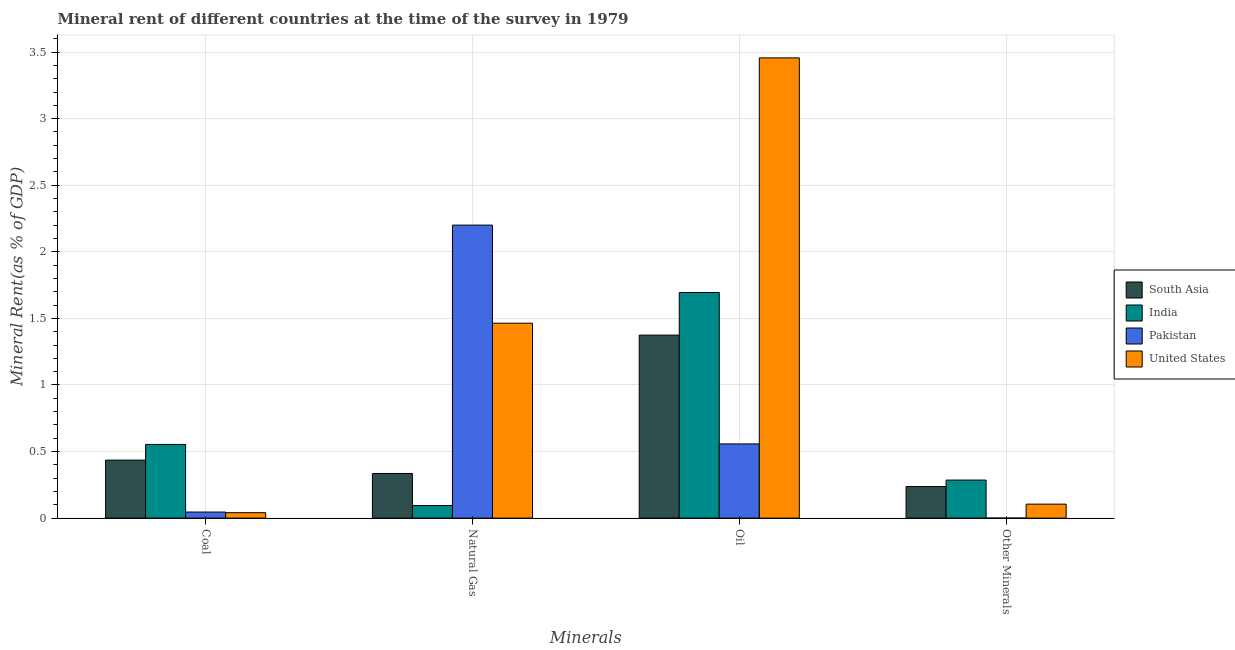How many different coloured bars are there?
Keep it short and to the point. 4. How many groups of bars are there?
Give a very brief answer. 4. Are the number of bars per tick equal to the number of legend labels?
Ensure brevity in your answer.  Yes. How many bars are there on the 2nd tick from the right?
Give a very brief answer. 4. What is the label of the 2nd group of bars from the left?
Your answer should be very brief. Natural Gas. What is the natural gas rent in South Asia?
Your answer should be compact. 0.34. Across all countries, what is the maximum coal rent?
Offer a very short reply. 0.55. Across all countries, what is the minimum natural gas rent?
Make the answer very short. 0.09. What is the total  rent of other minerals in the graph?
Your answer should be very brief. 0.63. What is the difference between the  rent of other minerals in South Asia and that in United States?
Give a very brief answer. 0.13. What is the difference between the  rent of other minerals in Pakistan and the oil rent in South Asia?
Give a very brief answer. -1.37. What is the average  rent of other minerals per country?
Provide a succinct answer. 0.16. What is the difference between the  rent of other minerals and coal rent in South Asia?
Your answer should be very brief. -0.2. In how many countries, is the coal rent greater than 2.1 %?
Your answer should be very brief. 0. What is the ratio of the  rent of other minerals in India to that in United States?
Provide a succinct answer. 2.72. What is the difference between the highest and the second highest oil rent?
Offer a terse response. 1.76. What is the difference between the highest and the lowest oil rent?
Give a very brief answer. 2.9. Is it the case that in every country, the sum of the coal rent and natural gas rent is greater than the oil rent?
Provide a succinct answer. No. What is the difference between two consecutive major ticks on the Y-axis?
Ensure brevity in your answer.  0.5. Where does the legend appear in the graph?
Provide a succinct answer. Center right. How many legend labels are there?
Your response must be concise. 4. What is the title of the graph?
Offer a terse response. Mineral rent of different countries at the time of the survey in 1979. Does "Ghana" appear as one of the legend labels in the graph?
Your response must be concise. No. What is the label or title of the X-axis?
Your answer should be compact. Minerals. What is the label or title of the Y-axis?
Give a very brief answer. Mineral Rent(as % of GDP). What is the Mineral Rent(as % of GDP) of South Asia in Coal?
Your answer should be very brief. 0.44. What is the Mineral Rent(as % of GDP) in India in Coal?
Ensure brevity in your answer.  0.55. What is the Mineral Rent(as % of GDP) of Pakistan in Coal?
Offer a terse response. 0.05. What is the Mineral Rent(as % of GDP) in United States in Coal?
Your answer should be compact. 0.04. What is the Mineral Rent(as % of GDP) in South Asia in Natural Gas?
Your answer should be compact. 0.34. What is the Mineral Rent(as % of GDP) in India in Natural Gas?
Ensure brevity in your answer.  0.09. What is the Mineral Rent(as % of GDP) in Pakistan in Natural Gas?
Ensure brevity in your answer.  2.2. What is the Mineral Rent(as % of GDP) of United States in Natural Gas?
Your response must be concise. 1.46. What is the Mineral Rent(as % of GDP) in South Asia in Oil?
Your answer should be compact. 1.37. What is the Mineral Rent(as % of GDP) in India in Oil?
Your response must be concise. 1.69. What is the Mineral Rent(as % of GDP) in Pakistan in Oil?
Make the answer very short. 0.56. What is the Mineral Rent(as % of GDP) of United States in Oil?
Ensure brevity in your answer.  3.46. What is the Mineral Rent(as % of GDP) of South Asia in Other Minerals?
Provide a succinct answer. 0.24. What is the Mineral Rent(as % of GDP) in India in Other Minerals?
Your answer should be compact. 0.29. What is the Mineral Rent(as % of GDP) in Pakistan in Other Minerals?
Keep it short and to the point. 0. What is the Mineral Rent(as % of GDP) in United States in Other Minerals?
Offer a terse response. 0.1. Across all Minerals, what is the maximum Mineral Rent(as % of GDP) in South Asia?
Ensure brevity in your answer.  1.37. Across all Minerals, what is the maximum Mineral Rent(as % of GDP) of India?
Give a very brief answer. 1.69. Across all Minerals, what is the maximum Mineral Rent(as % of GDP) of Pakistan?
Your answer should be compact. 2.2. Across all Minerals, what is the maximum Mineral Rent(as % of GDP) in United States?
Ensure brevity in your answer.  3.46. Across all Minerals, what is the minimum Mineral Rent(as % of GDP) in South Asia?
Provide a succinct answer. 0.24. Across all Minerals, what is the minimum Mineral Rent(as % of GDP) of India?
Offer a terse response. 0.09. Across all Minerals, what is the minimum Mineral Rent(as % of GDP) in Pakistan?
Keep it short and to the point. 0. Across all Minerals, what is the minimum Mineral Rent(as % of GDP) of United States?
Your answer should be compact. 0.04. What is the total Mineral Rent(as % of GDP) of South Asia in the graph?
Offer a terse response. 2.38. What is the total Mineral Rent(as % of GDP) in India in the graph?
Provide a short and direct response. 2.63. What is the total Mineral Rent(as % of GDP) of Pakistan in the graph?
Keep it short and to the point. 2.8. What is the total Mineral Rent(as % of GDP) of United States in the graph?
Offer a very short reply. 5.07. What is the difference between the Mineral Rent(as % of GDP) of South Asia in Coal and that in Natural Gas?
Offer a very short reply. 0.1. What is the difference between the Mineral Rent(as % of GDP) of India in Coal and that in Natural Gas?
Keep it short and to the point. 0.46. What is the difference between the Mineral Rent(as % of GDP) in Pakistan in Coal and that in Natural Gas?
Your answer should be compact. -2.16. What is the difference between the Mineral Rent(as % of GDP) in United States in Coal and that in Natural Gas?
Provide a succinct answer. -1.42. What is the difference between the Mineral Rent(as % of GDP) of South Asia in Coal and that in Oil?
Your response must be concise. -0.94. What is the difference between the Mineral Rent(as % of GDP) in India in Coal and that in Oil?
Your answer should be compact. -1.14. What is the difference between the Mineral Rent(as % of GDP) in Pakistan in Coal and that in Oil?
Your answer should be very brief. -0.51. What is the difference between the Mineral Rent(as % of GDP) in United States in Coal and that in Oil?
Offer a terse response. -3.42. What is the difference between the Mineral Rent(as % of GDP) of South Asia in Coal and that in Other Minerals?
Ensure brevity in your answer.  0.2. What is the difference between the Mineral Rent(as % of GDP) of India in Coal and that in Other Minerals?
Give a very brief answer. 0.27. What is the difference between the Mineral Rent(as % of GDP) of Pakistan in Coal and that in Other Minerals?
Offer a very short reply. 0.05. What is the difference between the Mineral Rent(as % of GDP) of United States in Coal and that in Other Minerals?
Keep it short and to the point. -0.06. What is the difference between the Mineral Rent(as % of GDP) of South Asia in Natural Gas and that in Oil?
Offer a terse response. -1.04. What is the difference between the Mineral Rent(as % of GDP) of India in Natural Gas and that in Oil?
Ensure brevity in your answer.  -1.6. What is the difference between the Mineral Rent(as % of GDP) of Pakistan in Natural Gas and that in Oil?
Your response must be concise. 1.64. What is the difference between the Mineral Rent(as % of GDP) of United States in Natural Gas and that in Oil?
Your answer should be very brief. -1.99. What is the difference between the Mineral Rent(as % of GDP) in South Asia in Natural Gas and that in Other Minerals?
Provide a succinct answer. 0.1. What is the difference between the Mineral Rent(as % of GDP) in India in Natural Gas and that in Other Minerals?
Give a very brief answer. -0.19. What is the difference between the Mineral Rent(as % of GDP) in Pakistan in Natural Gas and that in Other Minerals?
Ensure brevity in your answer.  2.2. What is the difference between the Mineral Rent(as % of GDP) of United States in Natural Gas and that in Other Minerals?
Provide a short and direct response. 1.36. What is the difference between the Mineral Rent(as % of GDP) of South Asia in Oil and that in Other Minerals?
Provide a short and direct response. 1.14. What is the difference between the Mineral Rent(as % of GDP) of India in Oil and that in Other Minerals?
Provide a short and direct response. 1.41. What is the difference between the Mineral Rent(as % of GDP) of Pakistan in Oil and that in Other Minerals?
Offer a very short reply. 0.56. What is the difference between the Mineral Rent(as % of GDP) in United States in Oil and that in Other Minerals?
Your answer should be very brief. 3.35. What is the difference between the Mineral Rent(as % of GDP) in South Asia in Coal and the Mineral Rent(as % of GDP) in India in Natural Gas?
Your answer should be very brief. 0.34. What is the difference between the Mineral Rent(as % of GDP) of South Asia in Coal and the Mineral Rent(as % of GDP) of Pakistan in Natural Gas?
Your answer should be very brief. -1.77. What is the difference between the Mineral Rent(as % of GDP) of South Asia in Coal and the Mineral Rent(as % of GDP) of United States in Natural Gas?
Provide a short and direct response. -1.03. What is the difference between the Mineral Rent(as % of GDP) of India in Coal and the Mineral Rent(as % of GDP) of Pakistan in Natural Gas?
Your answer should be compact. -1.65. What is the difference between the Mineral Rent(as % of GDP) in India in Coal and the Mineral Rent(as % of GDP) in United States in Natural Gas?
Make the answer very short. -0.91. What is the difference between the Mineral Rent(as % of GDP) in Pakistan in Coal and the Mineral Rent(as % of GDP) in United States in Natural Gas?
Offer a terse response. -1.42. What is the difference between the Mineral Rent(as % of GDP) of South Asia in Coal and the Mineral Rent(as % of GDP) of India in Oil?
Provide a short and direct response. -1.26. What is the difference between the Mineral Rent(as % of GDP) in South Asia in Coal and the Mineral Rent(as % of GDP) in Pakistan in Oil?
Offer a very short reply. -0.12. What is the difference between the Mineral Rent(as % of GDP) in South Asia in Coal and the Mineral Rent(as % of GDP) in United States in Oil?
Offer a very short reply. -3.02. What is the difference between the Mineral Rent(as % of GDP) in India in Coal and the Mineral Rent(as % of GDP) in Pakistan in Oil?
Give a very brief answer. -0. What is the difference between the Mineral Rent(as % of GDP) in India in Coal and the Mineral Rent(as % of GDP) in United States in Oil?
Provide a short and direct response. -2.9. What is the difference between the Mineral Rent(as % of GDP) of Pakistan in Coal and the Mineral Rent(as % of GDP) of United States in Oil?
Give a very brief answer. -3.41. What is the difference between the Mineral Rent(as % of GDP) in South Asia in Coal and the Mineral Rent(as % of GDP) in India in Other Minerals?
Your response must be concise. 0.15. What is the difference between the Mineral Rent(as % of GDP) of South Asia in Coal and the Mineral Rent(as % of GDP) of Pakistan in Other Minerals?
Your response must be concise. 0.44. What is the difference between the Mineral Rent(as % of GDP) in South Asia in Coal and the Mineral Rent(as % of GDP) in United States in Other Minerals?
Ensure brevity in your answer.  0.33. What is the difference between the Mineral Rent(as % of GDP) in India in Coal and the Mineral Rent(as % of GDP) in Pakistan in Other Minerals?
Make the answer very short. 0.55. What is the difference between the Mineral Rent(as % of GDP) of India in Coal and the Mineral Rent(as % of GDP) of United States in Other Minerals?
Offer a terse response. 0.45. What is the difference between the Mineral Rent(as % of GDP) in Pakistan in Coal and the Mineral Rent(as % of GDP) in United States in Other Minerals?
Your answer should be compact. -0.06. What is the difference between the Mineral Rent(as % of GDP) of South Asia in Natural Gas and the Mineral Rent(as % of GDP) of India in Oil?
Provide a succinct answer. -1.36. What is the difference between the Mineral Rent(as % of GDP) in South Asia in Natural Gas and the Mineral Rent(as % of GDP) in Pakistan in Oil?
Make the answer very short. -0.22. What is the difference between the Mineral Rent(as % of GDP) of South Asia in Natural Gas and the Mineral Rent(as % of GDP) of United States in Oil?
Offer a very short reply. -3.12. What is the difference between the Mineral Rent(as % of GDP) of India in Natural Gas and the Mineral Rent(as % of GDP) of Pakistan in Oil?
Your response must be concise. -0.46. What is the difference between the Mineral Rent(as % of GDP) of India in Natural Gas and the Mineral Rent(as % of GDP) of United States in Oil?
Offer a very short reply. -3.36. What is the difference between the Mineral Rent(as % of GDP) of Pakistan in Natural Gas and the Mineral Rent(as % of GDP) of United States in Oil?
Your answer should be very brief. -1.26. What is the difference between the Mineral Rent(as % of GDP) in South Asia in Natural Gas and the Mineral Rent(as % of GDP) in India in Other Minerals?
Give a very brief answer. 0.05. What is the difference between the Mineral Rent(as % of GDP) of South Asia in Natural Gas and the Mineral Rent(as % of GDP) of Pakistan in Other Minerals?
Your response must be concise. 0.34. What is the difference between the Mineral Rent(as % of GDP) in South Asia in Natural Gas and the Mineral Rent(as % of GDP) in United States in Other Minerals?
Make the answer very short. 0.23. What is the difference between the Mineral Rent(as % of GDP) of India in Natural Gas and the Mineral Rent(as % of GDP) of Pakistan in Other Minerals?
Provide a succinct answer. 0.09. What is the difference between the Mineral Rent(as % of GDP) in India in Natural Gas and the Mineral Rent(as % of GDP) in United States in Other Minerals?
Give a very brief answer. -0.01. What is the difference between the Mineral Rent(as % of GDP) of Pakistan in Natural Gas and the Mineral Rent(as % of GDP) of United States in Other Minerals?
Your answer should be compact. 2.1. What is the difference between the Mineral Rent(as % of GDP) of South Asia in Oil and the Mineral Rent(as % of GDP) of India in Other Minerals?
Provide a short and direct response. 1.09. What is the difference between the Mineral Rent(as % of GDP) in South Asia in Oil and the Mineral Rent(as % of GDP) in Pakistan in Other Minerals?
Your response must be concise. 1.37. What is the difference between the Mineral Rent(as % of GDP) of South Asia in Oil and the Mineral Rent(as % of GDP) of United States in Other Minerals?
Provide a short and direct response. 1.27. What is the difference between the Mineral Rent(as % of GDP) of India in Oil and the Mineral Rent(as % of GDP) of Pakistan in Other Minerals?
Your answer should be very brief. 1.69. What is the difference between the Mineral Rent(as % of GDP) of India in Oil and the Mineral Rent(as % of GDP) of United States in Other Minerals?
Provide a succinct answer. 1.59. What is the difference between the Mineral Rent(as % of GDP) in Pakistan in Oil and the Mineral Rent(as % of GDP) in United States in Other Minerals?
Your answer should be very brief. 0.45. What is the average Mineral Rent(as % of GDP) of South Asia per Minerals?
Offer a very short reply. 0.6. What is the average Mineral Rent(as % of GDP) in India per Minerals?
Offer a very short reply. 0.66. What is the average Mineral Rent(as % of GDP) in Pakistan per Minerals?
Give a very brief answer. 0.7. What is the average Mineral Rent(as % of GDP) in United States per Minerals?
Offer a terse response. 1.27. What is the difference between the Mineral Rent(as % of GDP) in South Asia and Mineral Rent(as % of GDP) in India in Coal?
Ensure brevity in your answer.  -0.12. What is the difference between the Mineral Rent(as % of GDP) of South Asia and Mineral Rent(as % of GDP) of Pakistan in Coal?
Provide a short and direct response. 0.39. What is the difference between the Mineral Rent(as % of GDP) of South Asia and Mineral Rent(as % of GDP) of United States in Coal?
Offer a very short reply. 0.39. What is the difference between the Mineral Rent(as % of GDP) in India and Mineral Rent(as % of GDP) in Pakistan in Coal?
Offer a very short reply. 0.51. What is the difference between the Mineral Rent(as % of GDP) in India and Mineral Rent(as % of GDP) in United States in Coal?
Your response must be concise. 0.51. What is the difference between the Mineral Rent(as % of GDP) of Pakistan and Mineral Rent(as % of GDP) of United States in Coal?
Your response must be concise. 0. What is the difference between the Mineral Rent(as % of GDP) of South Asia and Mineral Rent(as % of GDP) of India in Natural Gas?
Provide a short and direct response. 0.24. What is the difference between the Mineral Rent(as % of GDP) in South Asia and Mineral Rent(as % of GDP) in Pakistan in Natural Gas?
Your answer should be compact. -1.87. What is the difference between the Mineral Rent(as % of GDP) in South Asia and Mineral Rent(as % of GDP) in United States in Natural Gas?
Your response must be concise. -1.13. What is the difference between the Mineral Rent(as % of GDP) of India and Mineral Rent(as % of GDP) of Pakistan in Natural Gas?
Give a very brief answer. -2.11. What is the difference between the Mineral Rent(as % of GDP) of India and Mineral Rent(as % of GDP) of United States in Natural Gas?
Your response must be concise. -1.37. What is the difference between the Mineral Rent(as % of GDP) in Pakistan and Mineral Rent(as % of GDP) in United States in Natural Gas?
Keep it short and to the point. 0.74. What is the difference between the Mineral Rent(as % of GDP) in South Asia and Mineral Rent(as % of GDP) in India in Oil?
Offer a very short reply. -0.32. What is the difference between the Mineral Rent(as % of GDP) in South Asia and Mineral Rent(as % of GDP) in Pakistan in Oil?
Offer a very short reply. 0.82. What is the difference between the Mineral Rent(as % of GDP) in South Asia and Mineral Rent(as % of GDP) in United States in Oil?
Give a very brief answer. -2.08. What is the difference between the Mineral Rent(as % of GDP) in India and Mineral Rent(as % of GDP) in Pakistan in Oil?
Provide a succinct answer. 1.14. What is the difference between the Mineral Rent(as % of GDP) in India and Mineral Rent(as % of GDP) in United States in Oil?
Make the answer very short. -1.76. What is the difference between the Mineral Rent(as % of GDP) in Pakistan and Mineral Rent(as % of GDP) in United States in Oil?
Your answer should be compact. -2.9. What is the difference between the Mineral Rent(as % of GDP) in South Asia and Mineral Rent(as % of GDP) in India in Other Minerals?
Provide a short and direct response. -0.05. What is the difference between the Mineral Rent(as % of GDP) in South Asia and Mineral Rent(as % of GDP) in Pakistan in Other Minerals?
Offer a terse response. 0.24. What is the difference between the Mineral Rent(as % of GDP) in South Asia and Mineral Rent(as % of GDP) in United States in Other Minerals?
Your response must be concise. 0.13. What is the difference between the Mineral Rent(as % of GDP) in India and Mineral Rent(as % of GDP) in Pakistan in Other Minerals?
Provide a succinct answer. 0.29. What is the difference between the Mineral Rent(as % of GDP) in India and Mineral Rent(as % of GDP) in United States in Other Minerals?
Keep it short and to the point. 0.18. What is the difference between the Mineral Rent(as % of GDP) of Pakistan and Mineral Rent(as % of GDP) of United States in Other Minerals?
Offer a terse response. -0.1. What is the ratio of the Mineral Rent(as % of GDP) of South Asia in Coal to that in Natural Gas?
Provide a short and direct response. 1.3. What is the ratio of the Mineral Rent(as % of GDP) in India in Coal to that in Natural Gas?
Give a very brief answer. 5.87. What is the ratio of the Mineral Rent(as % of GDP) in Pakistan in Coal to that in Natural Gas?
Ensure brevity in your answer.  0.02. What is the ratio of the Mineral Rent(as % of GDP) in United States in Coal to that in Natural Gas?
Give a very brief answer. 0.03. What is the ratio of the Mineral Rent(as % of GDP) of South Asia in Coal to that in Oil?
Your response must be concise. 0.32. What is the ratio of the Mineral Rent(as % of GDP) in India in Coal to that in Oil?
Your answer should be compact. 0.33. What is the ratio of the Mineral Rent(as % of GDP) of Pakistan in Coal to that in Oil?
Provide a short and direct response. 0.08. What is the ratio of the Mineral Rent(as % of GDP) of United States in Coal to that in Oil?
Offer a very short reply. 0.01. What is the ratio of the Mineral Rent(as % of GDP) in South Asia in Coal to that in Other Minerals?
Offer a terse response. 1.84. What is the ratio of the Mineral Rent(as % of GDP) in India in Coal to that in Other Minerals?
Your answer should be very brief. 1.94. What is the ratio of the Mineral Rent(as % of GDP) in Pakistan in Coal to that in Other Minerals?
Your response must be concise. 379.28. What is the ratio of the Mineral Rent(as % of GDP) in United States in Coal to that in Other Minerals?
Offer a terse response. 0.39. What is the ratio of the Mineral Rent(as % of GDP) in South Asia in Natural Gas to that in Oil?
Your answer should be very brief. 0.24. What is the ratio of the Mineral Rent(as % of GDP) in India in Natural Gas to that in Oil?
Provide a succinct answer. 0.06. What is the ratio of the Mineral Rent(as % of GDP) in Pakistan in Natural Gas to that in Oil?
Keep it short and to the point. 3.95. What is the ratio of the Mineral Rent(as % of GDP) of United States in Natural Gas to that in Oil?
Provide a succinct answer. 0.42. What is the ratio of the Mineral Rent(as % of GDP) in South Asia in Natural Gas to that in Other Minerals?
Your response must be concise. 1.41. What is the ratio of the Mineral Rent(as % of GDP) of India in Natural Gas to that in Other Minerals?
Give a very brief answer. 0.33. What is the ratio of the Mineral Rent(as % of GDP) of Pakistan in Natural Gas to that in Other Minerals?
Keep it short and to the point. 1.83e+04. What is the ratio of the Mineral Rent(as % of GDP) in United States in Natural Gas to that in Other Minerals?
Your answer should be compact. 13.95. What is the ratio of the Mineral Rent(as % of GDP) in South Asia in Oil to that in Other Minerals?
Make the answer very short. 5.79. What is the ratio of the Mineral Rent(as % of GDP) of India in Oil to that in Other Minerals?
Your answer should be compact. 5.93. What is the ratio of the Mineral Rent(as % of GDP) in Pakistan in Oil to that in Other Minerals?
Provide a short and direct response. 4634.06. What is the ratio of the Mineral Rent(as % of GDP) of United States in Oil to that in Other Minerals?
Provide a short and direct response. 32.93. What is the difference between the highest and the second highest Mineral Rent(as % of GDP) of South Asia?
Keep it short and to the point. 0.94. What is the difference between the highest and the second highest Mineral Rent(as % of GDP) in India?
Offer a terse response. 1.14. What is the difference between the highest and the second highest Mineral Rent(as % of GDP) of Pakistan?
Provide a succinct answer. 1.64. What is the difference between the highest and the second highest Mineral Rent(as % of GDP) of United States?
Your answer should be compact. 1.99. What is the difference between the highest and the lowest Mineral Rent(as % of GDP) in South Asia?
Offer a terse response. 1.14. What is the difference between the highest and the lowest Mineral Rent(as % of GDP) of India?
Your answer should be compact. 1.6. What is the difference between the highest and the lowest Mineral Rent(as % of GDP) of Pakistan?
Give a very brief answer. 2.2. What is the difference between the highest and the lowest Mineral Rent(as % of GDP) of United States?
Give a very brief answer. 3.42. 